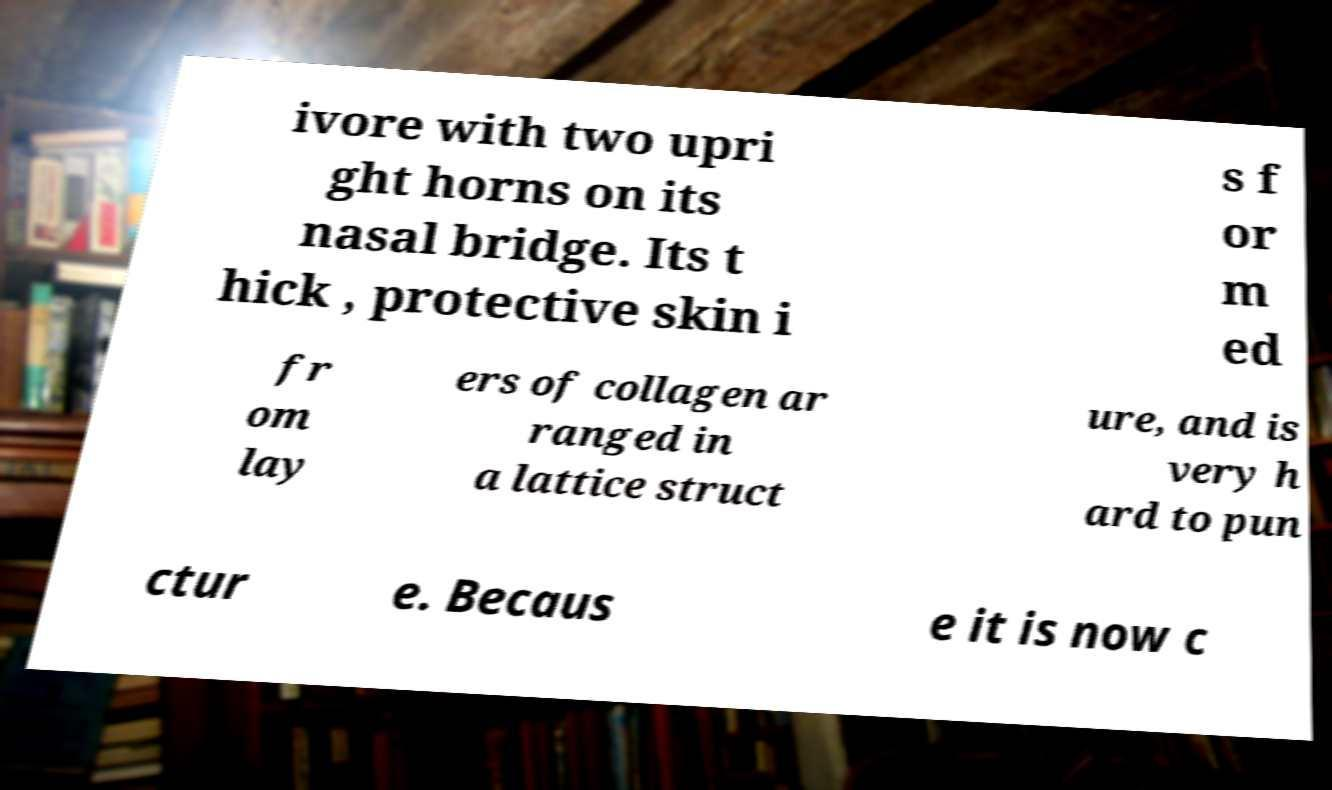Please read and relay the text visible in this image. What does it say? ivore with two upri ght horns on its nasal bridge. Its t hick , protective skin i s f or m ed fr om lay ers of collagen ar ranged in a lattice struct ure, and is very h ard to pun ctur e. Becaus e it is now c 